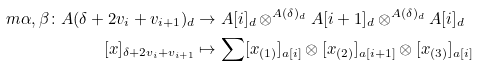Convert formula to latex. <formula><loc_0><loc_0><loc_500><loc_500>\ m { \alpha , \beta } \colon A ( \delta + 2 v _ { i } + v _ { i + 1 } ) _ { d } & \to A [ i ] _ { d } \otimes ^ { A ( \delta ) _ { d } } A [ i + 1 ] _ { d } \otimes ^ { A ( \delta ) _ { d } } A [ i ] _ { d } \\ [ x ] _ { \delta + 2 v _ { i } + v _ { i + 1 } } & \mapsto \sum [ x _ { ( 1 ) } ] _ { a [ i ] } \otimes [ x _ { ( 2 ) } ] _ { a [ i + 1 ] } \otimes [ x _ { ( 3 ) } ] _ { a [ i ] }</formula> 